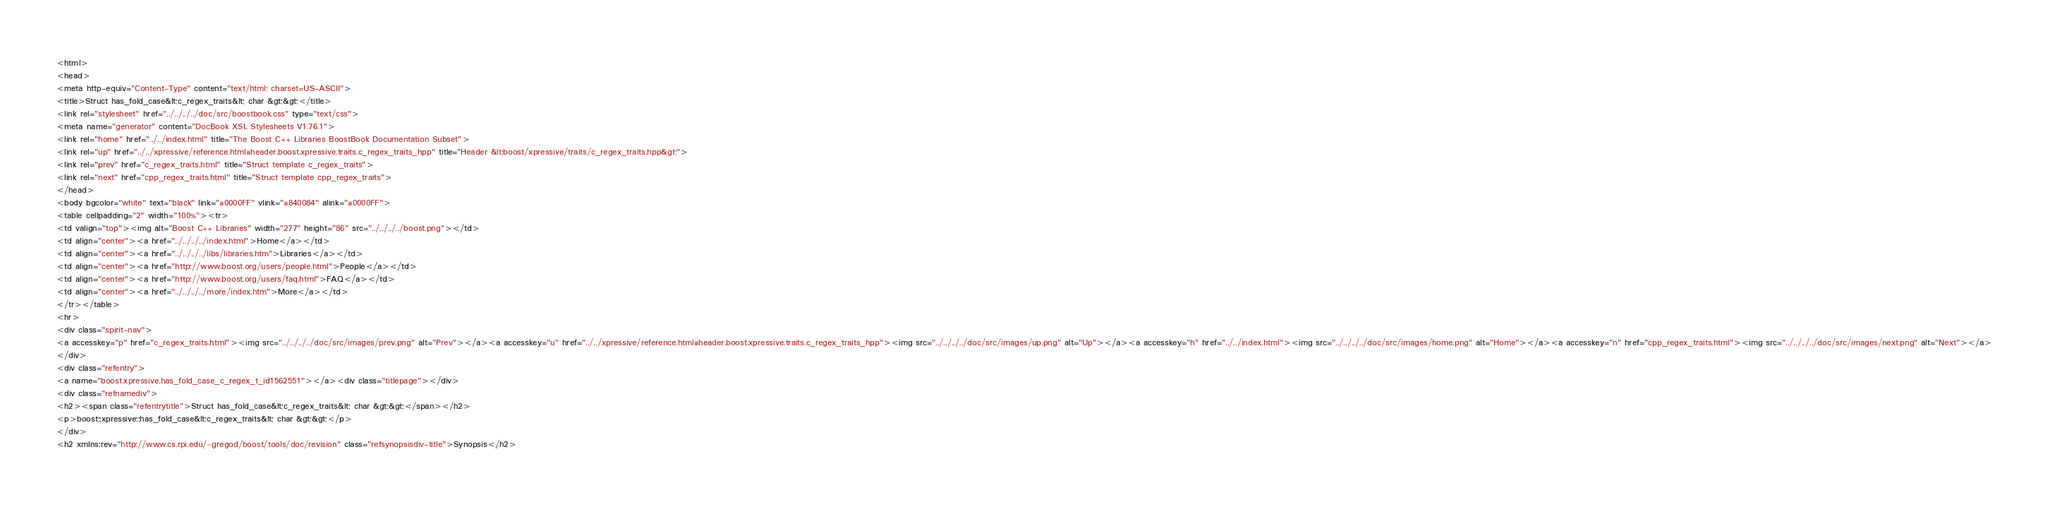<code> <loc_0><loc_0><loc_500><loc_500><_HTML_><html>
<head>
<meta http-equiv="Content-Type" content="text/html; charset=US-ASCII">
<title>Struct has_fold_case&lt;c_regex_traits&lt; char &gt;&gt;</title>
<link rel="stylesheet" href="../../../../doc/src/boostbook.css" type="text/css">
<meta name="generator" content="DocBook XSL Stylesheets V1.76.1">
<link rel="home" href="../../index.html" title="The Boost C++ Libraries BoostBook Documentation Subset">
<link rel="up" href="../../xpressive/reference.html#header.boost.xpressive.traits.c_regex_traits_hpp" title="Header &lt;boost/xpressive/traits/c_regex_traits.hpp&gt;">
<link rel="prev" href="c_regex_traits.html" title="Struct template c_regex_traits">
<link rel="next" href="cpp_regex_traits.html" title="Struct template cpp_regex_traits">
</head>
<body bgcolor="white" text="black" link="#0000FF" vlink="#840084" alink="#0000FF">
<table cellpadding="2" width="100%"><tr>
<td valign="top"><img alt="Boost C++ Libraries" width="277" height="86" src="../../../../boost.png"></td>
<td align="center"><a href="../../../../index.html">Home</a></td>
<td align="center"><a href="../../../../libs/libraries.htm">Libraries</a></td>
<td align="center"><a href="http://www.boost.org/users/people.html">People</a></td>
<td align="center"><a href="http://www.boost.org/users/faq.html">FAQ</a></td>
<td align="center"><a href="../../../../more/index.htm">More</a></td>
</tr></table>
<hr>
<div class="spirit-nav">
<a accesskey="p" href="c_regex_traits.html"><img src="../../../../doc/src/images/prev.png" alt="Prev"></a><a accesskey="u" href="../../xpressive/reference.html#header.boost.xpressive.traits.c_regex_traits_hpp"><img src="../../../../doc/src/images/up.png" alt="Up"></a><a accesskey="h" href="../../index.html"><img src="../../../../doc/src/images/home.png" alt="Home"></a><a accesskey="n" href="cpp_regex_traits.html"><img src="../../../../doc/src/images/next.png" alt="Next"></a>
</div>
<div class="refentry">
<a name="boost.xpressive.has_fold_case_c_regex_t_id1562551"></a><div class="titlepage"></div>
<div class="refnamediv">
<h2><span class="refentrytitle">Struct has_fold_case&lt;c_regex_traits&lt; char &gt;&gt;</span></h2>
<p>boost::xpressive::has_fold_case&lt;c_regex_traits&lt; char &gt;&gt;</p>
</div>
<h2 xmlns:rev="http://www.cs.rpi.edu/~gregod/boost/tools/doc/revision" class="refsynopsisdiv-title">Synopsis</h2></code> 